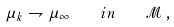<formula> <loc_0><loc_0><loc_500><loc_500>\mu _ { k } \rightharpoondown \mu _ { \infty } \quad i n \quad \mathcal { M } \, ,</formula> 